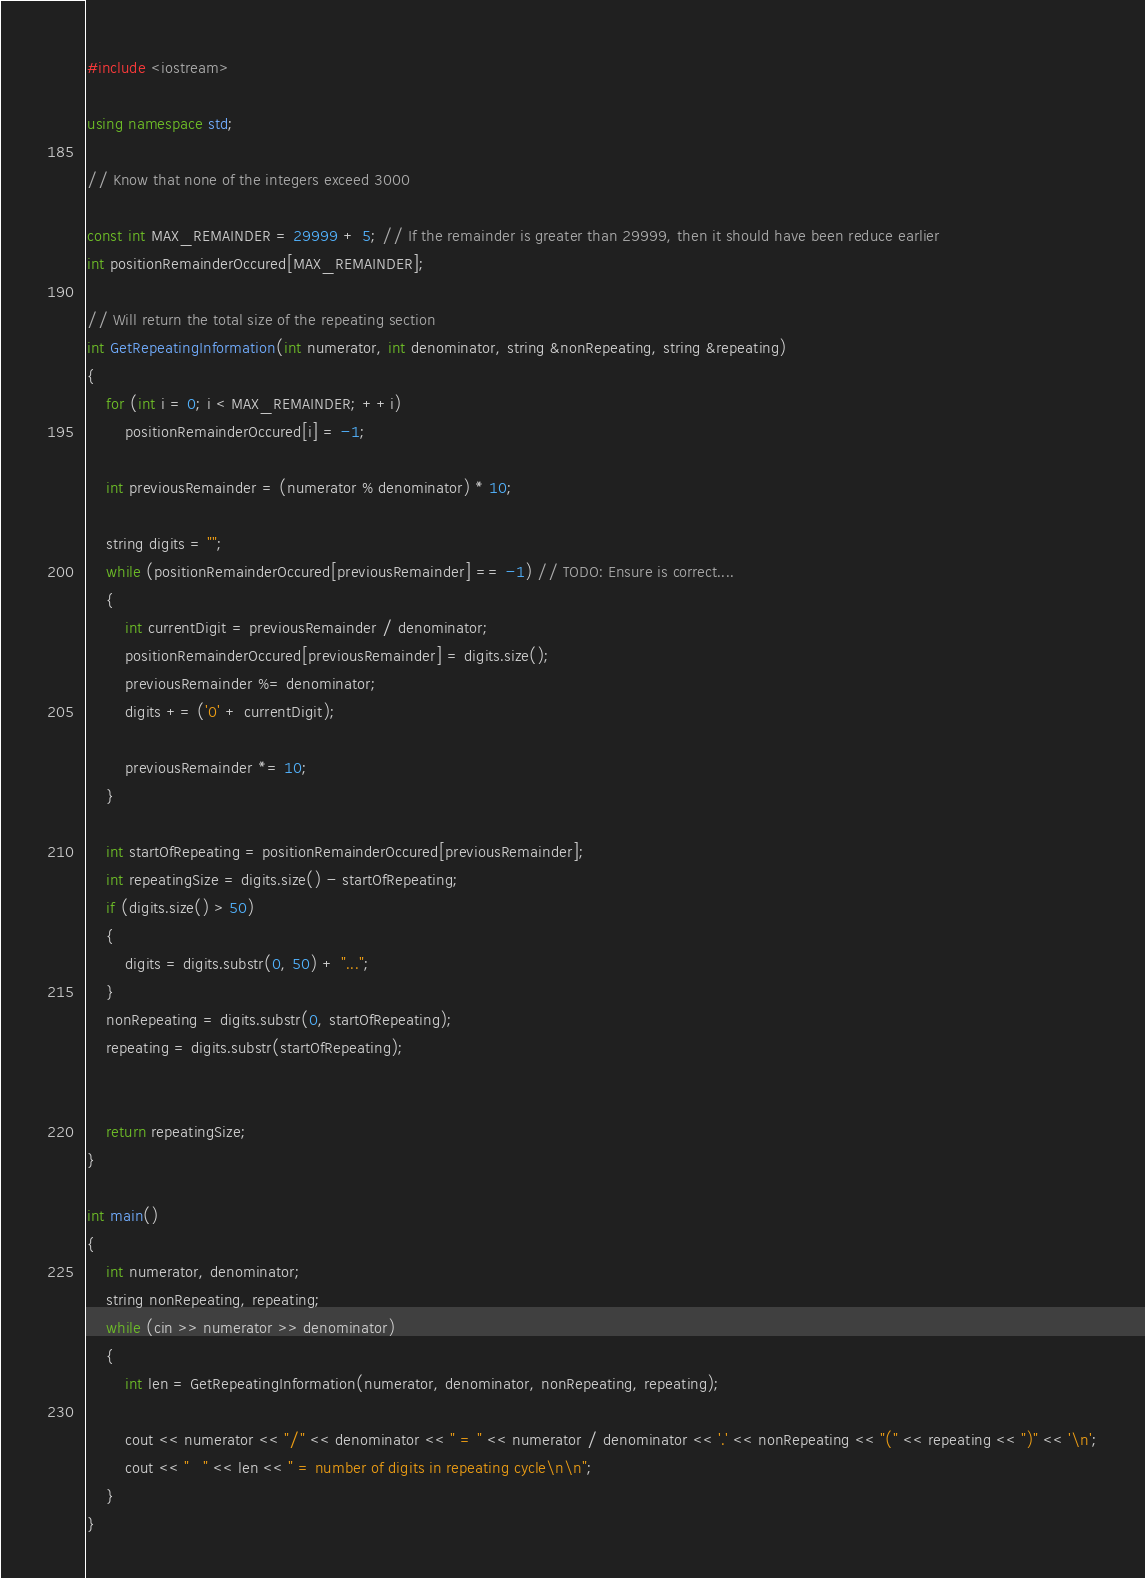Convert code to text. <code><loc_0><loc_0><loc_500><loc_500><_C++_>#include <iostream>

using namespace std;

// Know that none of the integers exceed 3000

const int MAX_REMAINDER = 29999 + 5; // If the remainder is greater than 29999, then it should have been reduce earlier
int positionRemainderOccured[MAX_REMAINDER];

// Will return the total size of the repeating section
int GetRepeatingInformation(int numerator, int denominator, string &nonRepeating, string &repeating)
{
    for (int i = 0; i < MAX_REMAINDER; ++i)
        positionRemainderOccured[i] = -1;
    
    int previousRemainder = (numerator % denominator) * 10;
    
    string digits = "";
    while (positionRemainderOccured[previousRemainder] == -1) // TODO: Ensure is correct....
    {
        int currentDigit = previousRemainder / denominator;
        positionRemainderOccured[previousRemainder] = digits.size();
        previousRemainder %= denominator;
        digits += ('0' + currentDigit);
        
        previousRemainder *= 10;
    }
    
    int startOfRepeating = positionRemainderOccured[previousRemainder];
    int repeatingSize = digits.size() - startOfRepeating;
    if (digits.size() > 50)
    {
        digits = digits.substr(0, 50) + "...";
    }
    nonRepeating = digits.substr(0, startOfRepeating);
    repeating = digits.substr(startOfRepeating);
    
    
    return repeatingSize;
}

int main()
{
    int numerator, denominator;
    string nonRepeating, repeating;
    while (cin >> numerator >> denominator)
    {
        int len = GetRepeatingInformation(numerator, denominator, nonRepeating, repeating);
        
        cout << numerator << "/" << denominator << " = " << numerator / denominator << '.' << nonRepeating << "(" << repeating << ")" << '\n';
        cout << "   " << len << " = number of digits in repeating cycle\n\n";
    }
}</code> 